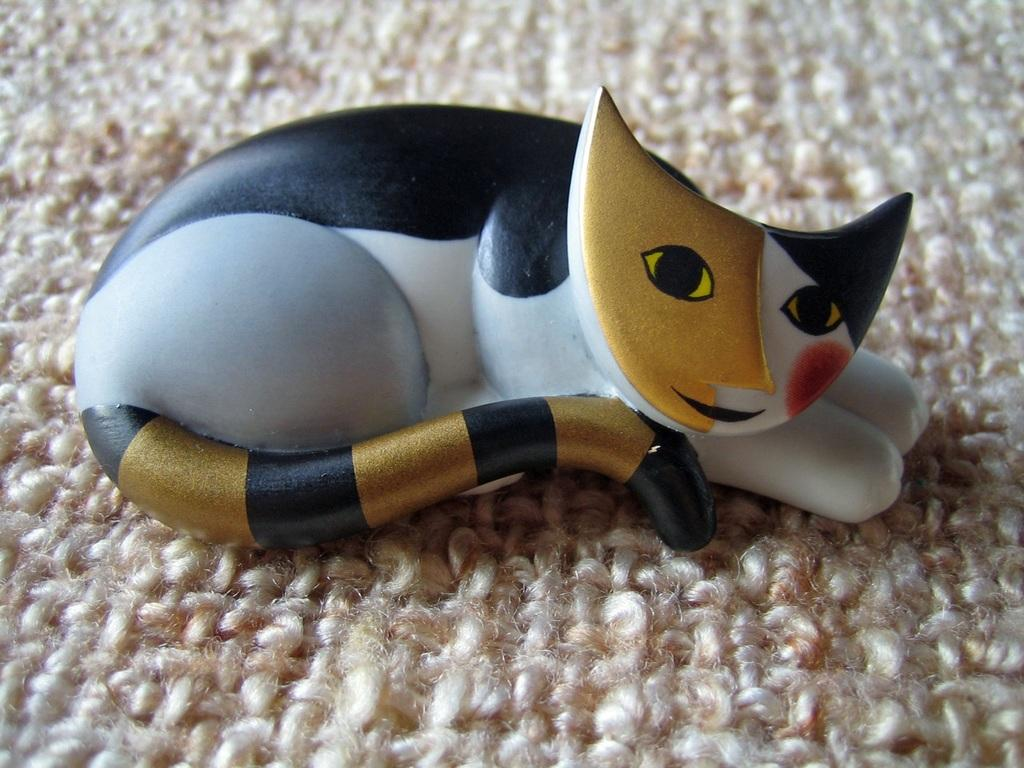What is the main object in the middle of the image? There is a toy in the middle of the image. What can be seen in the background of the image? There is a mat in the background of the image. What type of drug is being used by the toy in the image? There is no drug present in the image; it features a toy and a mat. How many sticks are being held by the toy in the image? There are no sticks present in the image; it features a toy and a mat. 